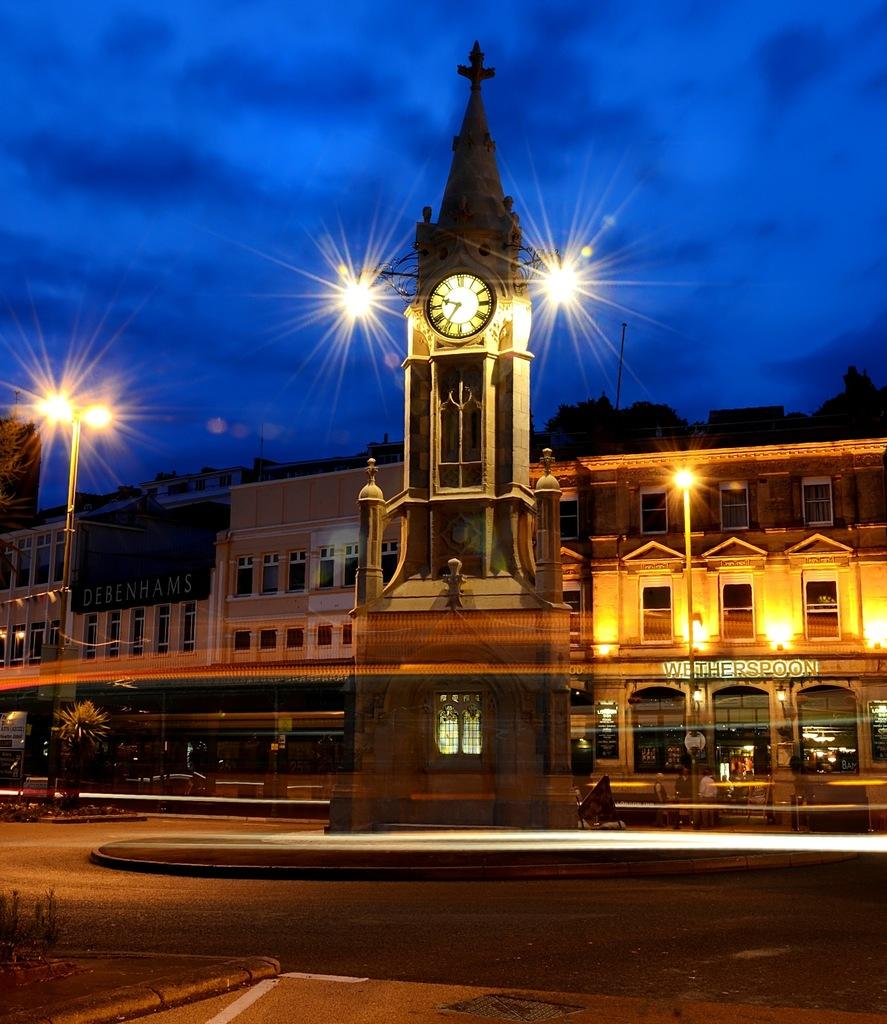What is the main structure in the image? There is a clock tower in the image. What can be seen on the buildings in the image? The buildings have windows in the image. What type of establishments are present in the image? There are shops in the image. What is the purpose of the pole in the image? There is a light pole in the image. What is the landscape feature in the front bottom side of the image? There is a road in the front bottom side of the image. Can you see a deer crossing the road in the image? There is no deer present in the image; it only features a clock tower, buildings, shops, a light pole, and a road. 